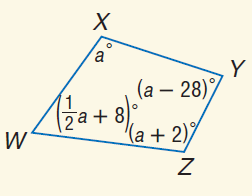Answer the mathemtical geometry problem and directly provide the correct option letter.
Question: Find m \angle W.
Choices: A: 31 B: 62 C: 108 D: 124 B 